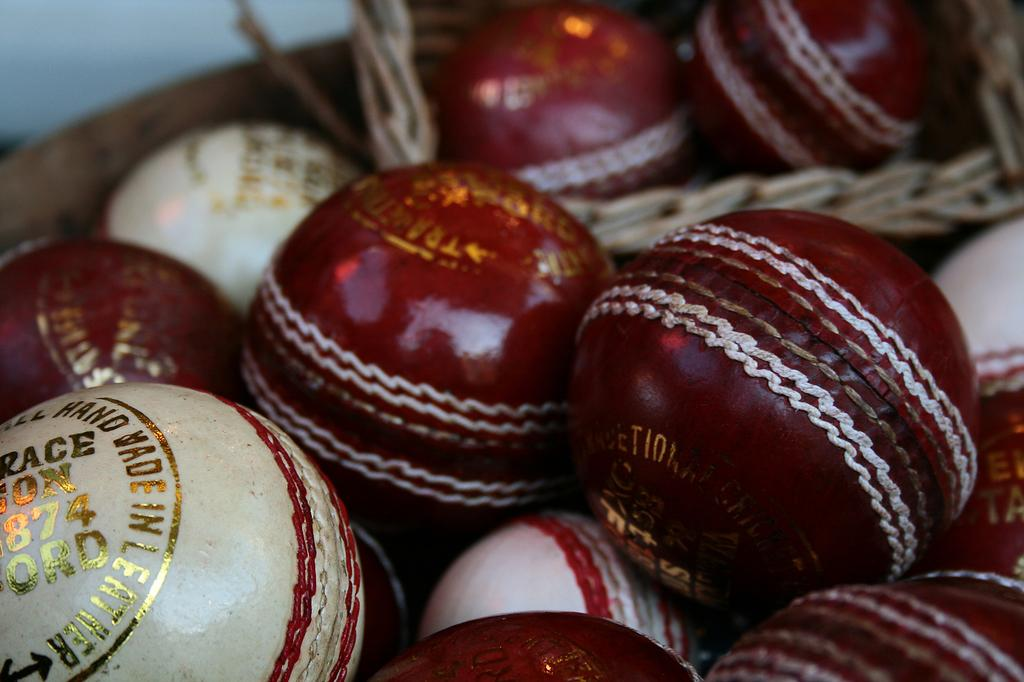What colors are the balls in the image? There are red and white colored balls in the image. What is written on the balls? Something is written in golden color on the balls. How does the digestion process affect the balls in the image? There is no indication of digestion in the image, as it only features balls with writing on them. 